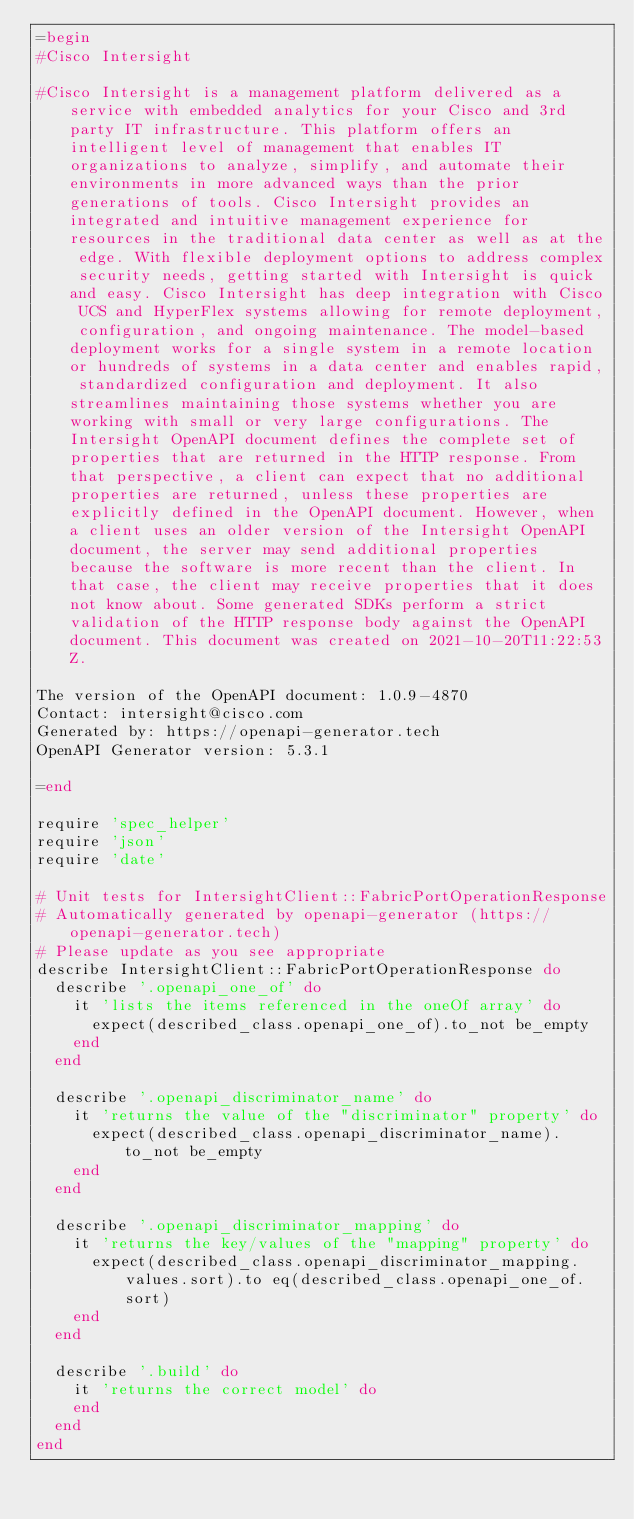<code> <loc_0><loc_0><loc_500><loc_500><_Ruby_>=begin
#Cisco Intersight

#Cisco Intersight is a management platform delivered as a service with embedded analytics for your Cisco and 3rd party IT infrastructure. This platform offers an intelligent level of management that enables IT organizations to analyze, simplify, and automate their environments in more advanced ways than the prior generations of tools. Cisco Intersight provides an integrated and intuitive management experience for resources in the traditional data center as well as at the edge. With flexible deployment options to address complex security needs, getting started with Intersight is quick and easy. Cisco Intersight has deep integration with Cisco UCS and HyperFlex systems allowing for remote deployment, configuration, and ongoing maintenance. The model-based deployment works for a single system in a remote location or hundreds of systems in a data center and enables rapid, standardized configuration and deployment. It also streamlines maintaining those systems whether you are working with small or very large configurations. The Intersight OpenAPI document defines the complete set of properties that are returned in the HTTP response. From that perspective, a client can expect that no additional properties are returned, unless these properties are explicitly defined in the OpenAPI document. However, when a client uses an older version of the Intersight OpenAPI document, the server may send additional properties because the software is more recent than the client. In that case, the client may receive properties that it does not know about. Some generated SDKs perform a strict validation of the HTTP response body against the OpenAPI document. This document was created on 2021-10-20T11:22:53Z.

The version of the OpenAPI document: 1.0.9-4870
Contact: intersight@cisco.com
Generated by: https://openapi-generator.tech
OpenAPI Generator version: 5.3.1

=end

require 'spec_helper'
require 'json'
require 'date'

# Unit tests for IntersightClient::FabricPortOperationResponse
# Automatically generated by openapi-generator (https://openapi-generator.tech)
# Please update as you see appropriate
describe IntersightClient::FabricPortOperationResponse do
  describe '.openapi_one_of' do
    it 'lists the items referenced in the oneOf array' do
      expect(described_class.openapi_one_of).to_not be_empty
    end
  end

  describe '.openapi_discriminator_name' do
    it 'returns the value of the "discriminator" property' do
      expect(described_class.openapi_discriminator_name).to_not be_empty
    end
  end

  describe '.openapi_discriminator_mapping' do
    it 'returns the key/values of the "mapping" property' do
      expect(described_class.openapi_discriminator_mapping.values.sort).to eq(described_class.openapi_one_of.sort)
    end
  end

  describe '.build' do
    it 'returns the correct model' do
    end
  end
end
</code> 